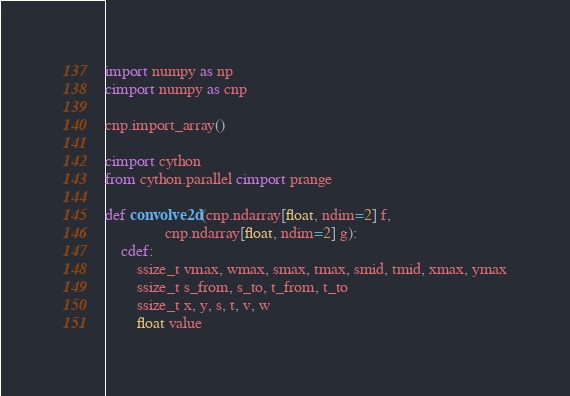Convert code to text. <code><loc_0><loc_0><loc_500><loc_500><_Cython_>import numpy as np
cimport numpy as cnp

cnp.import_array()

cimport cython
from cython.parallel cimport prange

def convolve2d(cnp.ndarray[float, ndim=2] f,
               cnp.ndarray[float, ndim=2] g):
    cdef:
        ssize_t vmax, wmax, smax, tmax, smid, tmid, xmax, ymax
        ssize_t s_from, s_to, t_from, t_to
        ssize_t x, y, s, t, v, w
        float value</code> 